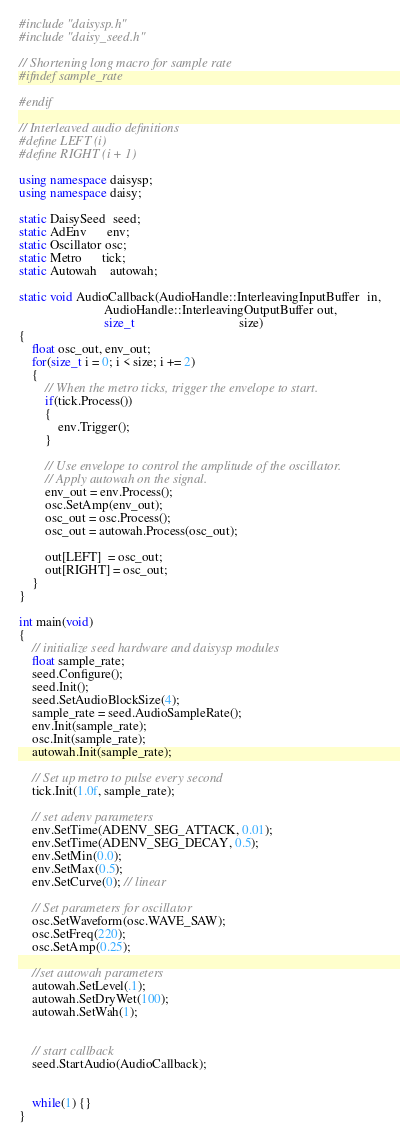Convert code to text. <code><loc_0><loc_0><loc_500><loc_500><_C++_>#include "daisysp.h"
#include "daisy_seed.h"

// Shortening long macro for sample rate
#ifndef sample_rate

#endif

// Interleaved audio definitions
#define LEFT (i)
#define RIGHT (i + 1)

using namespace daisysp;
using namespace daisy;

static DaisySeed  seed;
static AdEnv      env;
static Oscillator osc;
static Metro      tick;
static Autowah    autowah;

static void AudioCallback(AudioHandle::InterleavingInputBuffer  in,
                          AudioHandle::InterleavingOutputBuffer out,
                          size_t                                size)
{
    float osc_out, env_out;
    for(size_t i = 0; i < size; i += 2)
    {
        // When the metro ticks, trigger the envelope to start.
        if(tick.Process())
        {
            env.Trigger();
        }

        // Use envelope to control the amplitude of the oscillator.
        // Apply autowah on the signal.
        env_out = env.Process();
        osc.SetAmp(env_out);
        osc_out = osc.Process();
        osc_out = autowah.Process(osc_out);

        out[LEFT]  = osc_out;
        out[RIGHT] = osc_out;
    }
}

int main(void)
{
    // initialize seed hardware and daisysp modules
    float sample_rate;
    seed.Configure();
    seed.Init();
    seed.SetAudioBlockSize(4);
    sample_rate = seed.AudioSampleRate();
    env.Init(sample_rate);
    osc.Init(sample_rate);
    autowah.Init(sample_rate);

    // Set up metro to pulse every second
    tick.Init(1.0f, sample_rate);

    // set adenv parameters
    env.SetTime(ADENV_SEG_ATTACK, 0.01);
    env.SetTime(ADENV_SEG_DECAY, 0.5);
    env.SetMin(0.0);
    env.SetMax(0.5);
    env.SetCurve(0); // linear

    // Set parameters for oscillator
    osc.SetWaveform(osc.WAVE_SAW);
    osc.SetFreq(220);
    osc.SetAmp(0.25);

    //set autowah parameters
    autowah.SetLevel(.1);
    autowah.SetDryWet(100);
    autowah.SetWah(1);


    // start callback
    seed.StartAudio(AudioCallback);


    while(1) {}
}
</code> 